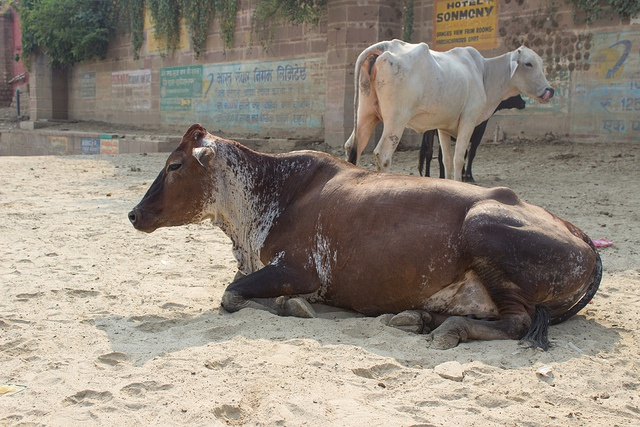Describe the objects in this image and their specific colors. I can see cow in darkgray, black, gray, and maroon tones, cow in darkgray and gray tones, and cow in darkgray, black, and gray tones in this image. 